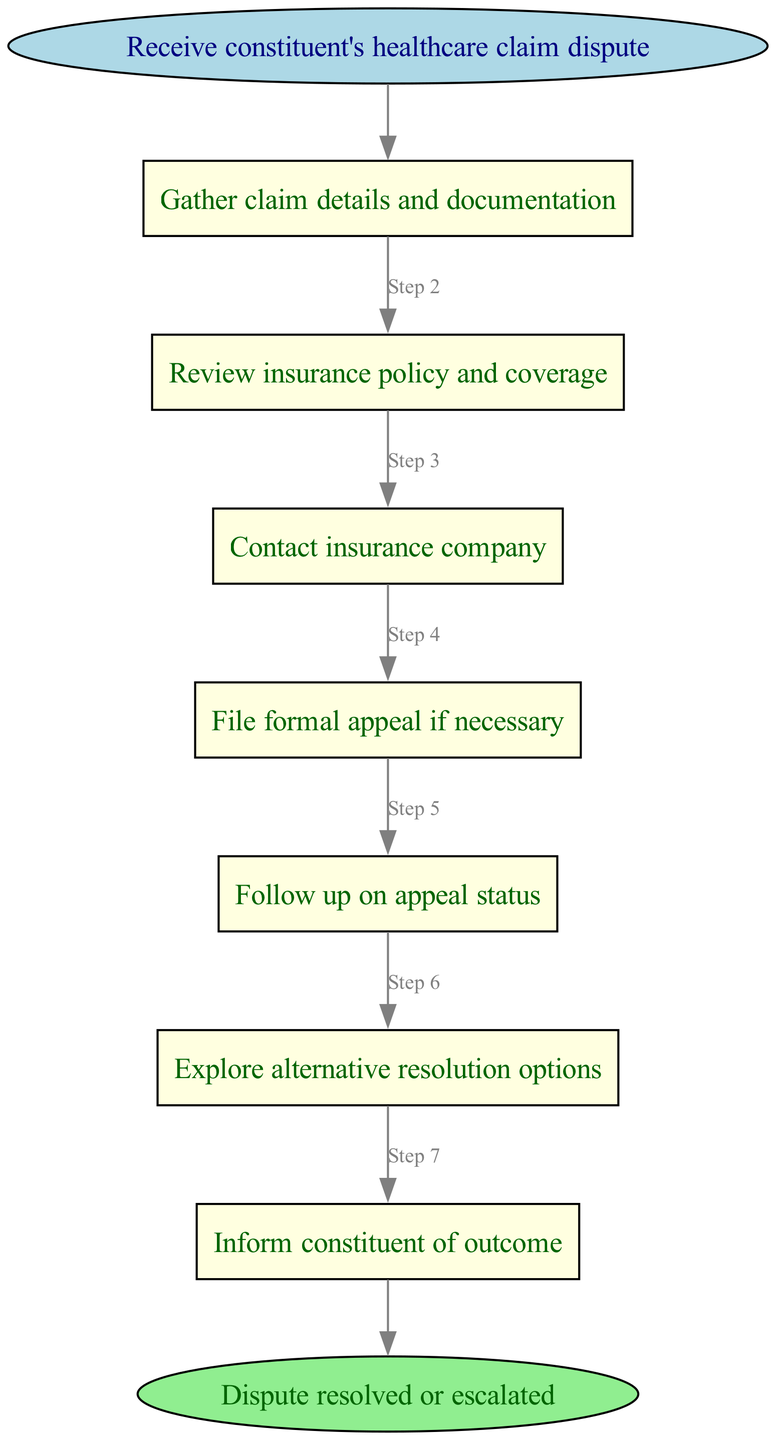What is the first step in the dispute resolution process? The diagram indicates that the first step is "Gather claim details and documentation," which is the action taken after receiving the constituent's healthcare claim dispute.
Answer: Gather claim details and documentation How many steps are there in total before resolution? By reviewing the flowchart, there are 6 process steps outlined before reaching the end node. This is confirmed by counting the steps listed in the diagram.
Answer: 6 What is the last action taken before informing the constituent? The diagram shows that the last action before informing the constituent is "Explore alternative resolution options," which is step 6. This connects directly to the final outcome of informing the constituent.
Answer: Explore alternative resolution options Which step involves communication with the insurance company? According to the diagram, the step that entails communication with the insurance company is step 3, labeled "Contact insurance company." This step follows reviewing the insurance policy.
Answer: Contact insurance company What happens if a formal appeal is filed? The process explicitly states that if a formal appeal is filed, the subsequent action is to "Follow up on appeal status," which is step 5. This shows a direct flow from filing the appeal to monitoring its progress.
Answer: Follow up on appeal status How many edges connect the steps in this process? Counting the edges shown in the diagram connecting steps, there are a total of 7 edges leading from one step to the next, culminating in the end node.
Answer: 7 What is the purpose of the end node? The end node in the diagram clearly signifies the conclusion of the process, indicating whether the dispute has been "resolved or escalated," thereby marking the outcome of the entire claim dispute process.
Answer: Dispute resolved or escalated 